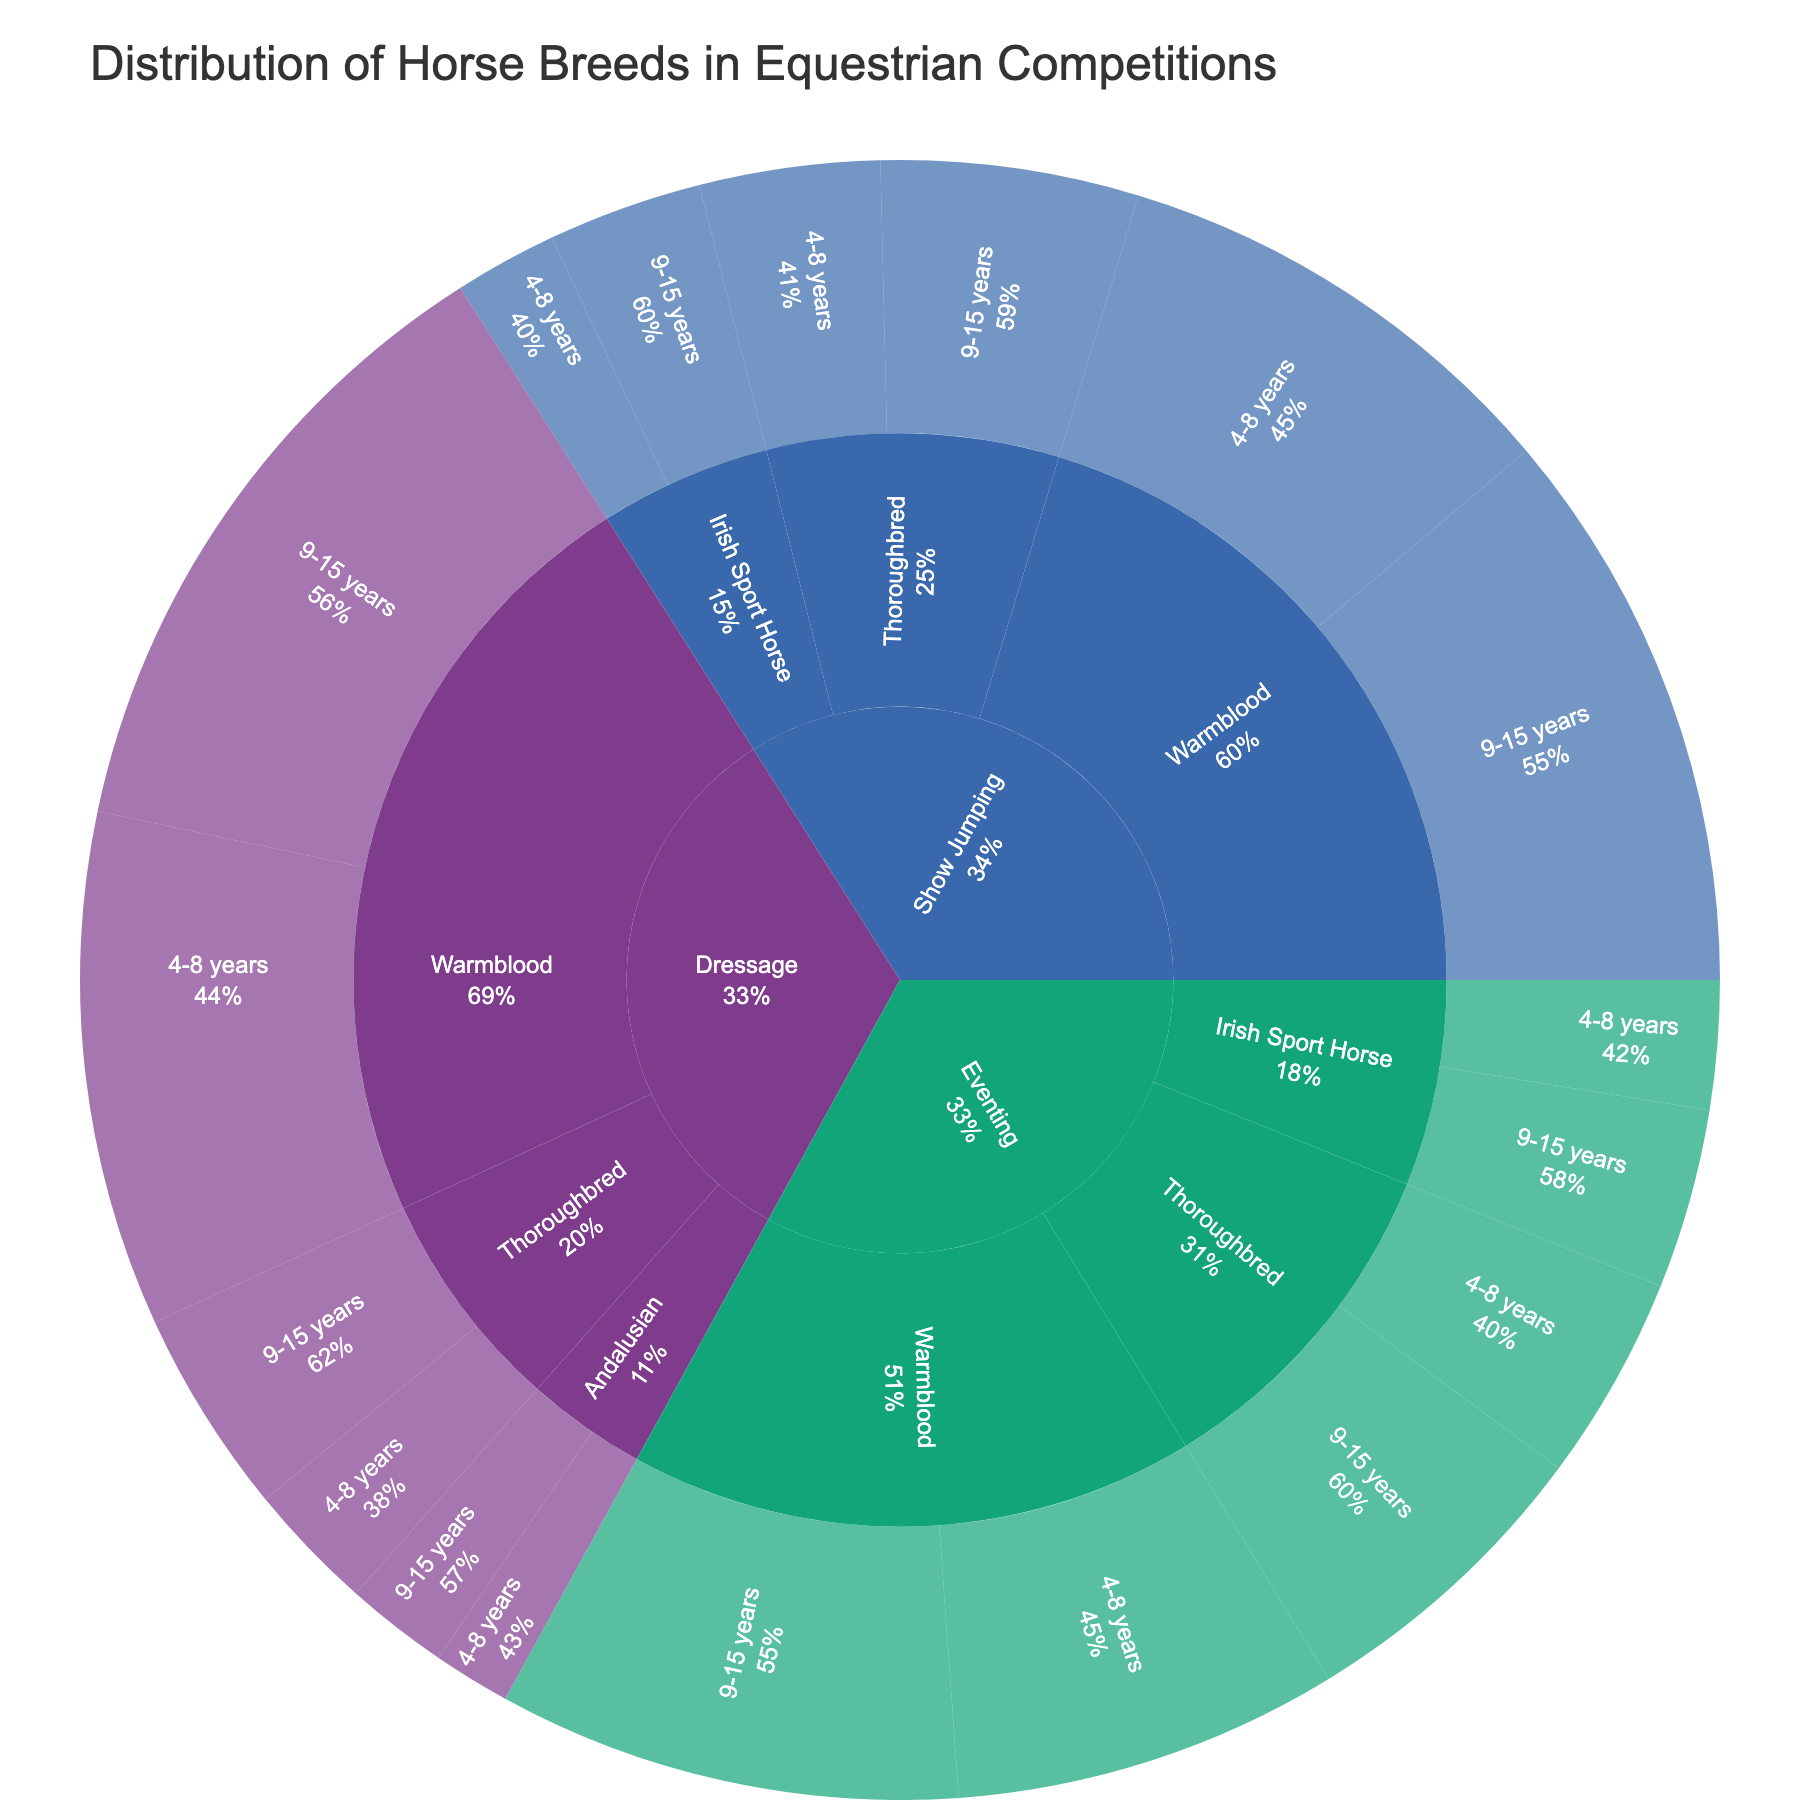what is the highest percentage of Warmbloods in any discipline and age group? To find the highest percentage, we look at each subcategory of Warmbloods across all disciplines and age groups. Warmbloods in Dressage for the 9-15 years group have the highest percentage of 25%.
Answer: 25% Which discipline has the smallest representation of Thoroughbreds? To determine this, we compare the percentages of Thoroughbreds across Dressage, Show Jumping, and Eventing. The smallest representation is in Dressage, with a total of 13% (4-8 years: 5%, 9-15 years: 8%).
Answer: Dressage How does the percentage of 4-8 years old Thoroughbreds in Eventing compare to the 4-8 years old Thoroughbreds in Dressage? We need to compare the corresponding percentages in the two disciplines. For Eventing, it is 8%, and for Dressage, it is 5%.
Answer: Eventing has 3% more What is the combined percentage of Warmbloods in all age groups within Show Jumping? Add the percentages of Warmbloods in Show Jumping: 4-8 years (18%), and 9-15 years (22%). 18% + 22% = 40%.
Answer: 40% Which discipline has the most diverse breeds represented? To determine this, we count the number of different breeds in each discipline. Dressage and Eventing have three breeds each, while Show Jumping has three as well. All disciplines are equally diverse in terms of breed representation.
Answer: All disciplines are equally diverse In which age group are Warmbloods most common overall? Sum the percentages of Warmbloods in the 4-8 years and 9-15 years age groups across all disciplines. 4-8 years (20+18+15 = 53%) and 9-15 years (25+22+18 = 65%). Warmbloods are most common in the 9-15 years age group.
Answer: 9-15 years How does the total percentage of all breeds in Dressage compare to the total in Show Jumping? Sum the percentages of all breeds in each discipline: Dressage (20+25+5+8+3+4 = 65%) and Show Jumping (18+22+7+10+4+6 = 67%). Show Jumping has a 2% higher total.
Answer: Show Jumping has 2% more 